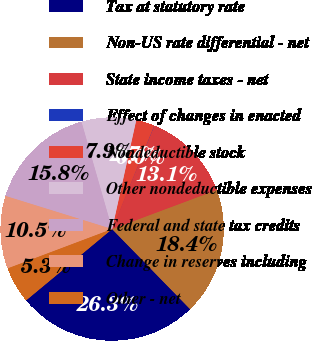Convert chart. <chart><loc_0><loc_0><loc_500><loc_500><pie_chart><fcel>Tax at statutory rate<fcel>Non-US rate differential - net<fcel>State income taxes - net<fcel>Effect of changes in enacted<fcel>Nondeductible stock<fcel>Other nondeductible expenses<fcel>Federal and state tax credits<fcel>Change in reserves including<fcel>Other - net<nl><fcel>26.27%<fcel>18.4%<fcel>13.15%<fcel>0.03%<fcel>2.66%<fcel>7.9%<fcel>15.78%<fcel>10.53%<fcel>5.28%<nl></chart> 